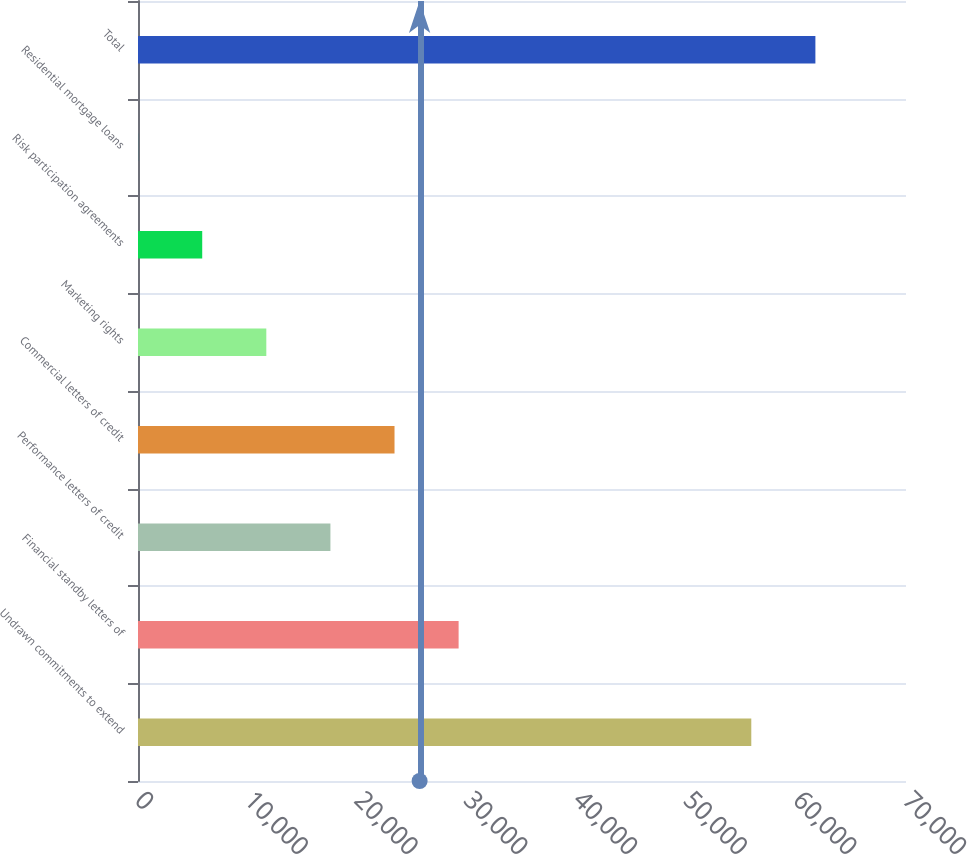<chart> <loc_0><loc_0><loc_500><loc_500><bar_chart><fcel>Undrawn commitments to extend<fcel>Financial standby letters of<fcel>Performance letters of credit<fcel>Commercial letters of credit<fcel>Marketing rights<fcel>Risk participation agreements<fcel>Residential mortgage loans<fcel>Total<nl><fcel>55899<fcel>29223<fcel>17538.2<fcel>23380.6<fcel>11695.8<fcel>5853.4<fcel>11<fcel>61741.4<nl></chart> 